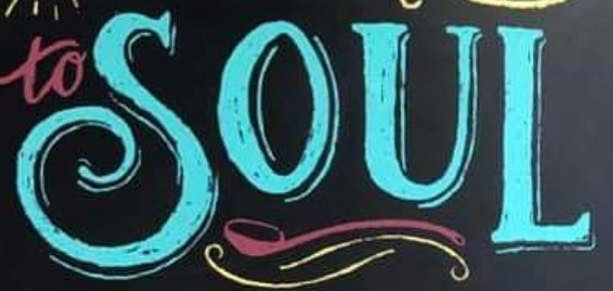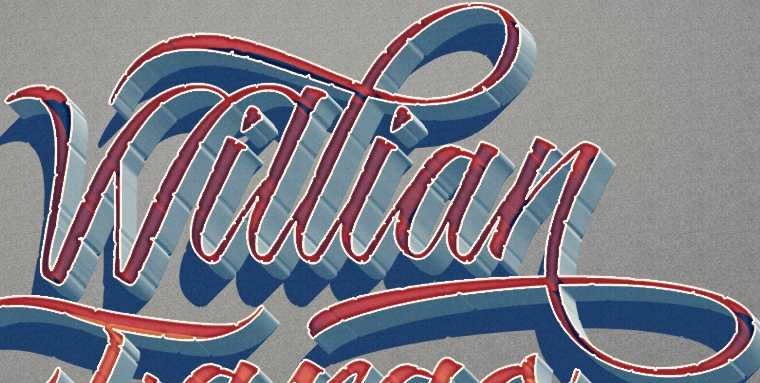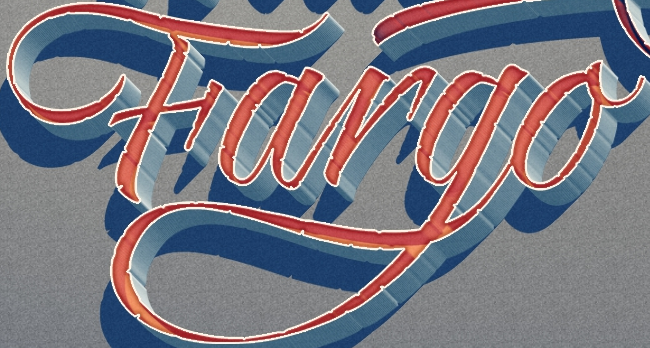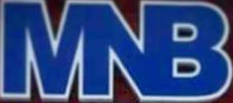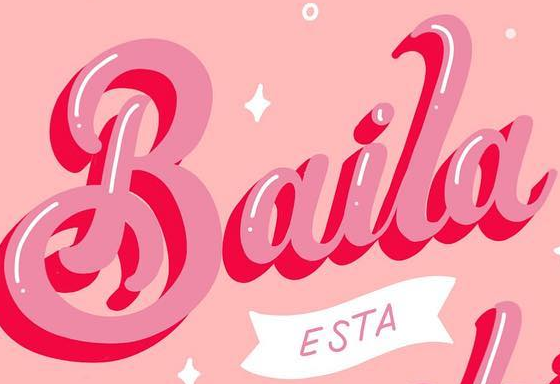What text is displayed in these images sequentially, separated by a semicolon? SOUL; Willian; Fargo; MNB; Baila 